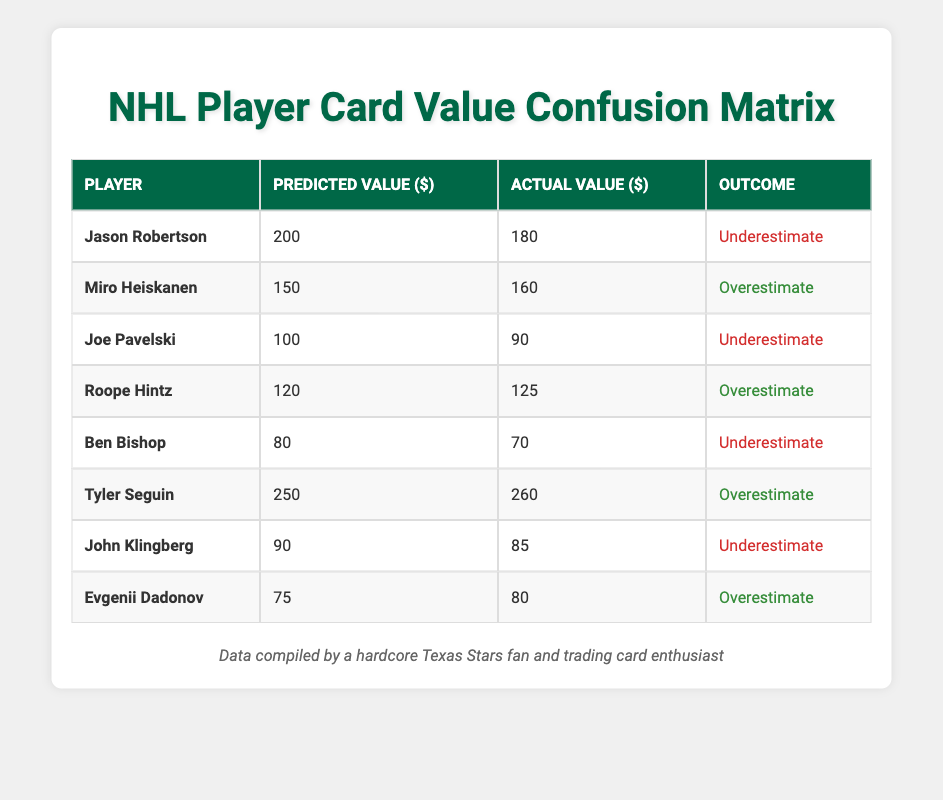What was the predicted value for Tyler Seguin? The table lists Tyler Seguin in the row with his details. His predicted value is displayed under the "Predicted Value ($)" column, which shows 250.
Answer: 250 Which player had the highest predicted value? By reviewing the "Predicted Value ($)" column, Tyler Seguin has the highest value listed at 250, compared to others, which are either equal to or lower than this amount.
Answer: Tyler Seguin How many players were underestimated in their predicted values? To find the number of underestimated predictions, I count the rows where the "Outcome" is marked as "Underestimate". There are 4 players marked as underestimated.
Answer: 4 What is the average actual value of the players listed? I sum the actual values (180 + 160 + 90 + 125 + 70 + 260 + 85 + 80 = 1060) and divide by the number of players (8), resulting in an average of 1060 / 8 = 132.5.
Answer: 132.5 Did any player have the same predicted and actual value? By examining the table, there are no entries where the predicted value is equal to the actual value. Each row shows a discrepancy between the two values.
Answer: No What is the difference between the highest and lowest actual sales value? The highest actual value is 260 (Tyler Seguin) and the lowest is 70 (Ben Bishop). The difference is calculated as 260 - 70 = 190.
Answer: 190 Which outcome was more common: Overestimate or Underestimate? By counting the occurrences in the "Outcome" column, there are 4 instances of "Underestimate" and 4 instances of "Overestimate". The totals are equal for both categories.
Answer: Equal What player was both overestimated and had a predicted value less than 150? The player that fits these criteria can be found by filtering for both conditions in the table. Miro Heiskanen’s predicted value is 150, but he was overestimated. However, he does not meet both criteria as his predicted value is not less than 150.
Answer: None 